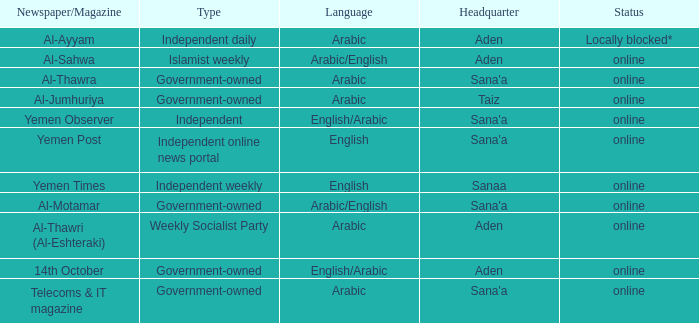What is Status, when Newspaper/Magazine is Al-Thawra? Online. Give me the full table as a dictionary. {'header': ['Newspaper/Magazine', 'Type', 'Language', 'Headquarter', 'Status'], 'rows': [['Al-Ayyam', 'Independent daily', 'Arabic', 'Aden', 'Locally blocked*'], ['Al-Sahwa', 'Islamist weekly', 'Arabic/English', 'Aden', 'online'], ['Al-Thawra', 'Government-owned', 'Arabic', "Sana'a", 'online'], ['Al-Jumhuriya', 'Government-owned', 'Arabic', 'Taiz', 'online'], ['Yemen Observer', 'Independent', 'English/Arabic', "Sana'a", 'online'], ['Yemen Post', 'Independent online news portal', 'English', "Sana'a", 'online'], ['Yemen Times', 'Independent weekly', 'English', 'Sanaa', 'online'], ['Al-Motamar', 'Government-owned', 'Arabic/English', "Sana'a", 'online'], ['Al-Thawri (Al-Eshteraki)', 'Weekly Socialist Party', 'Arabic', 'Aden', 'online'], ['14th October', 'Government-owned', 'English/Arabic', 'Aden', 'online'], ['Telecoms & IT magazine', 'Government-owned', 'Arabic', "Sana'a", 'online']]} 